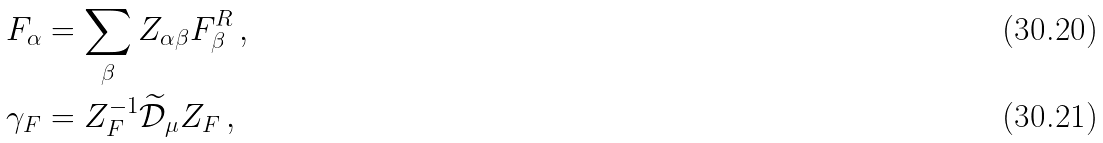<formula> <loc_0><loc_0><loc_500><loc_500>F _ { \alpha } & = \sum _ { \beta } Z _ { \alpha \beta } F ^ { R } _ { \beta } \, , \\ \gamma _ { F } & = Z _ { F } ^ { - 1 } \widetilde { \mathcal { D } } _ { \mu } Z _ { F } \, ,</formula> 